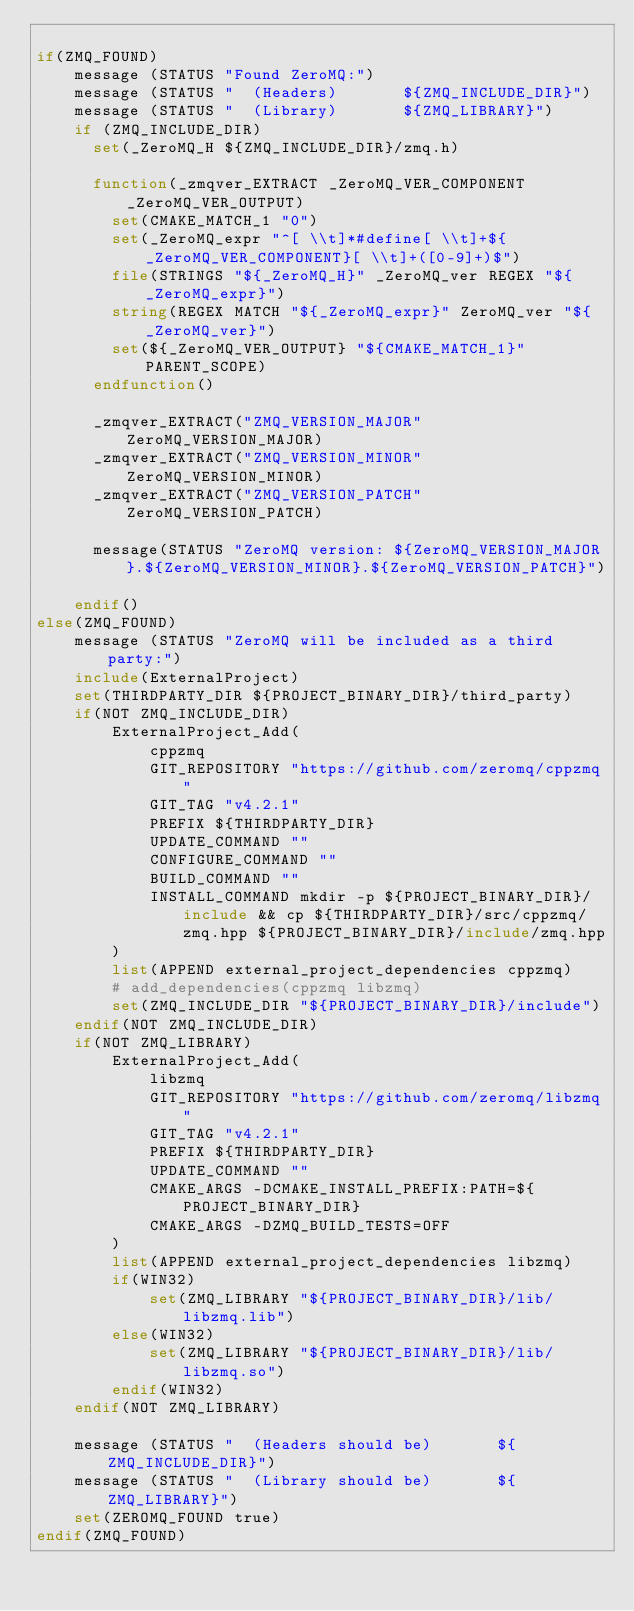<code> <loc_0><loc_0><loc_500><loc_500><_CMake_>
if(ZMQ_FOUND)
    message (STATUS "Found ZeroMQ:")
    message (STATUS "  (Headers)       ${ZMQ_INCLUDE_DIR}")
    message (STATUS "  (Library)       ${ZMQ_LIBRARY}")
    if (ZMQ_INCLUDE_DIR)
      set(_ZeroMQ_H ${ZMQ_INCLUDE_DIR}/zmq.h)

      function(_zmqver_EXTRACT _ZeroMQ_VER_COMPONENT _ZeroMQ_VER_OUTPUT)
        set(CMAKE_MATCH_1 "0")
        set(_ZeroMQ_expr "^[ \\t]*#define[ \\t]+${_ZeroMQ_VER_COMPONENT}[ \\t]+([0-9]+)$")
        file(STRINGS "${_ZeroMQ_H}" _ZeroMQ_ver REGEX "${_ZeroMQ_expr}")
        string(REGEX MATCH "${_ZeroMQ_expr}" ZeroMQ_ver "${_ZeroMQ_ver}")
        set(${_ZeroMQ_VER_OUTPUT} "${CMAKE_MATCH_1}" PARENT_SCOPE)
      endfunction()

      _zmqver_EXTRACT("ZMQ_VERSION_MAJOR" ZeroMQ_VERSION_MAJOR)
      _zmqver_EXTRACT("ZMQ_VERSION_MINOR" ZeroMQ_VERSION_MINOR)
      _zmqver_EXTRACT("ZMQ_VERSION_PATCH" ZeroMQ_VERSION_PATCH)

      message(STATUS "ZeroMQ version: ${ZeroMQ_VERSION_MAJOR}.${ZeroMQ_VERSION_MINOR}.${ZeroMQ_VERSION_PATCH}")

    endif()
else(ZMQ_FOUND)
    message (STATUS "ZeroMQ will be included as a third party:")
    include(ExternalProject)
    set(THIRDPARTY_DIR ${PROJECT_BINARY_DIR}/third_party)
    if(NOT ZMQ_INCLUDE_DIR)
        ExternalProject_Add(
            cppzmq
            GIT_REPOSITORY "https://github.com/zeromq/cppzmq"
            GIT_TAG "v4.2.1"
            PREFIX ${THIRDPARTY_DIR}
            UPDATE_COMMAND ""
            CONFIGURE_COMMAND ""
            BUILD_COMMAND ""
            INSTALL_COMMAND mkdir -p ${PROJECT_BINARY_DIR}/include && cp ${THIRDPARTY_DIR}/src/cppzmq/zmq.hpp ${PROJECT_BINARY_DIR}/include/zmq.hpp
        )
        list(APPEND external_project_dependencies cppzmq)
        # add_dependencies(cppzmq libzmq)
        set(ZMQ_INCLUDE_DIR "${PROJECT_BINARY_DIR}/include")
    endif(NOT ZMQ_INCLUDE_DIR)
    if(NOT ZMQ_LIBRARY)
        ExternalProject_Add(
            libzmq
            GIT_REPOSITORY "https://github.com/zeromq/libzmq"
            GIT_TAG "v4.2.1"
            PREFIX ${THIRDPARTY_DIR}
            UPDATE_COMMAND ""
            CMAKE_ARGS -DCMAKE_INSTALL_PREFIX:PATH=${PROJECT_BINARY_DIR}
            CMAKE_ARGS -DZMQ_BUILD_TESTS=OFF
        )
        list(APPEND external_project_dependencies libzmq)
        if(WIN32)
            set(ZMQ_LIBRARY "${PROJECT_BINARY_DIR}/lib/libzmq.lib")
        else(WIN32)
            set(ZMQ_LIBRARY "${PROJECT_BINARY_DIR}/lib/libzmq.so")
        endif(WIN32)
    endif(NOT ZMQ_LIBRARY)

    message (STATUS "  (Headers should be)       ${ZMQ_INCLUDE_DIR}")
    message (STATUS "  (Library should be)       ${ZMQ_LIBRARY}")
    set(ZEROMQ_FOUND true)
endif(ZMQ_FOUND)
</code> 